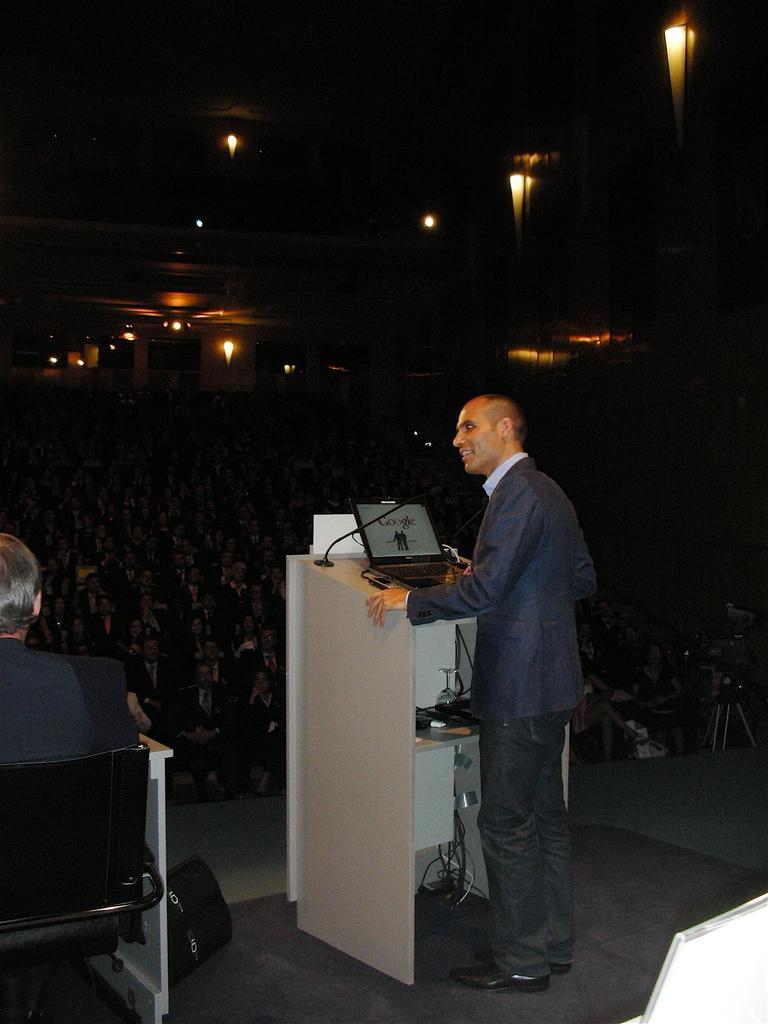Could you give a brief overview of what you see in this image? At the top we can see the ceiling and the lights. In this picture we can see a man sitting on a chair. We can see a black bag on the platform. On the right side of the picture we can see a man standing near to the podium and on the podium we can see a microphone and a laptop. We can see a camera and a stand. We can see the audience sitting on the chairs. 